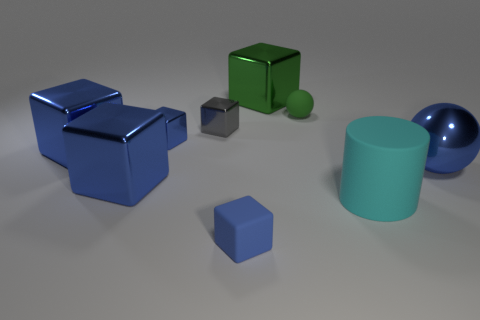Subtract all metallic cubes. How many cubes are left? 1 Subtract all red cylinders. How many blue blocks are left? 4 Subtract all gray blocks. How many blocks are left? 5 Add 1 large cyan shiny blocks. How many objects exist? 10 Subtract all red blocks. Subtract all cyan cylinders. How many blocks are left? 6 Subtract 1 cyan cylinders. How many objects are left? 8 Subtract all blocks. How many objects are left? 3 Subtract all green metallic blocks. Subtract all big spheres. How many objects are left? 7 Add 9 cylinders. How many cylinders are left? 10 Add 6 green rubber spheres. How many green rubber spheres exist? 7 